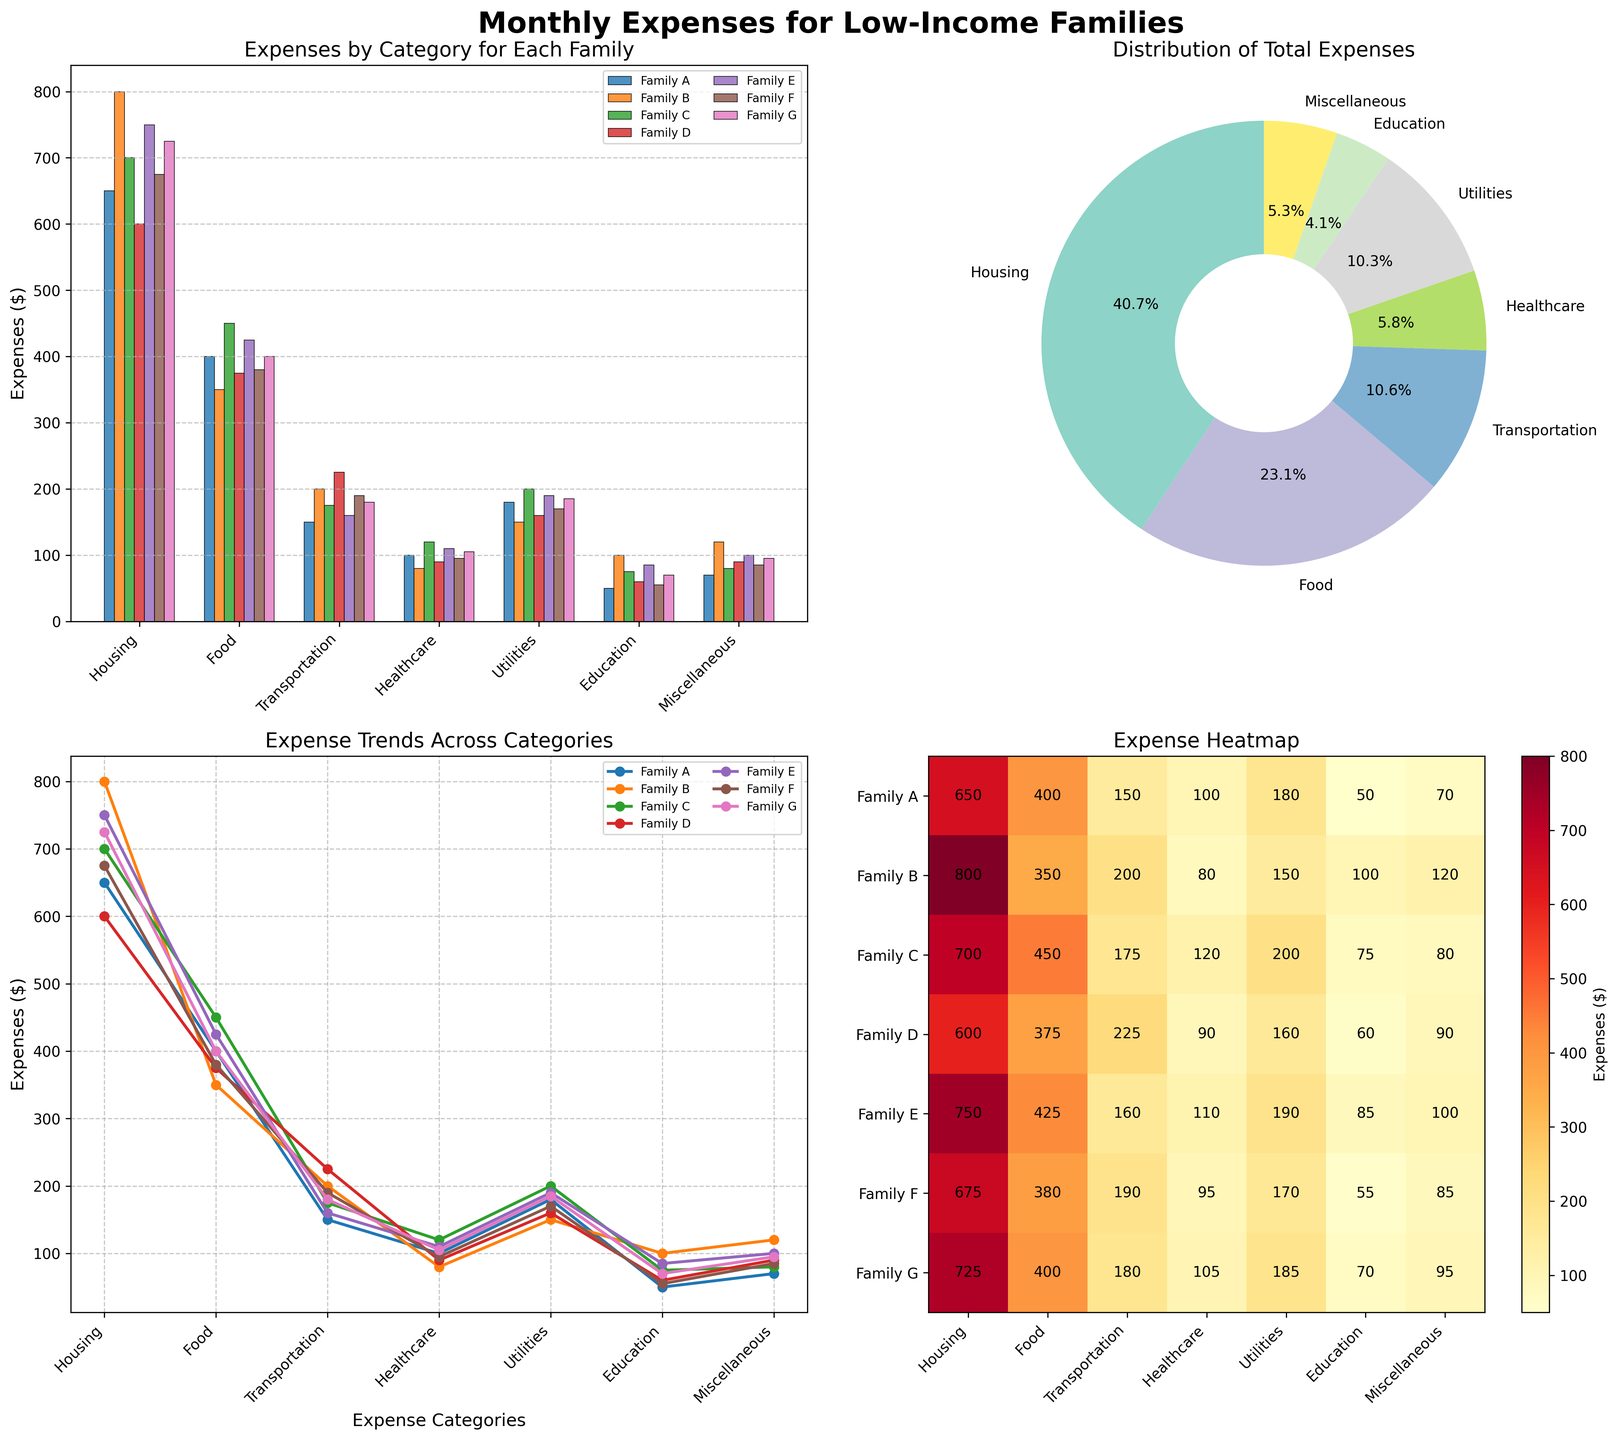What are the categories of expenses shown in the bar plot? The bar plot displays various expense categories on the x-axis, labeled "Housing", "Food", "Transportation", "Healthcare", "Utilities", "Education", and "Miscellaneous".
Answer: Housing, Food, Transportation, Healthcare, Utilities, Education, Miscellaneous Which family has the highest expense in the "Healthcare" category? By examining the bar heights for the "Healthcare" category in the bar plot, Family C has the highest expense.
Answer: Family C What is the total percentage of expenses attributed to "Housing" in the pie chart? The pie chart segment for "Housing" shows the percentage of total expenses. According to the chart, "Housing" accounts for 29.1% of the total expenses.
Answer: 29.1% Among all families, which expense category shows the most variation in the heatmap? By observing color intensity differences in the heatmap, "Transportation" shows a significant variation in color levels across all families.
Answer: Transportation How do the expenses for "Family D" in "Transportation" and "Food" compare? In the line plot, the markers for Family D in "Transportation" and "Food" show that "Transportation" expenses (225) are higher than "Food" expenses (375).
Answer: Transportation is higher Which family has the least combined expense on "Utilities" and "Miscellaneous"? Adding the expense values for "Utilities" and "Miscellaneous" for each family from the heatmap, Family B has the least combined expense: 150 (Utilities) + 120 (Miscellaneous) = 270.
Answer: Family B What trend is visible in the expenses for "Education" across different families in the line plot? The line plot shows that "Education" expenses vary moderately among families, with values ranging from 50 to 100, but no significant upward or downward trend is clear.
Answer: Moderate variation If Family G's "Housing" expenses were reduced by 10%, how would it compare with Family B's "Housing" expenses? Reducing Family G's "Housing" by 10% i.e., by 72.5 (725 * 0.1) gives a new expense of 652.5, which is still lower than Family B's "Housing" expenses of 800.
Answer: Family G's expenses would still be lower Which expense category accounts for the smallest percentage in the pie chart? Observing the smallest slice in the pie chart indicates that "Education" has the smallest percentage.
Answer: Education 